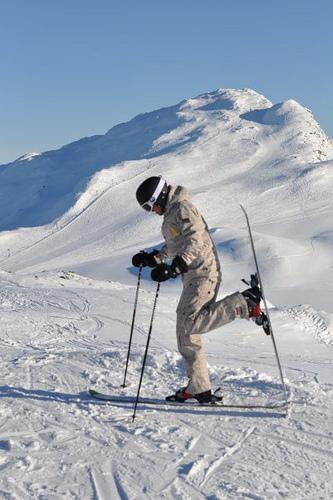How many feet are flat on the ground?
Keep it brief. 1. Is it cold in this picture?
Keep it brief. Yes. Is the man attempting to ski?
Quick response, please. Yes. 